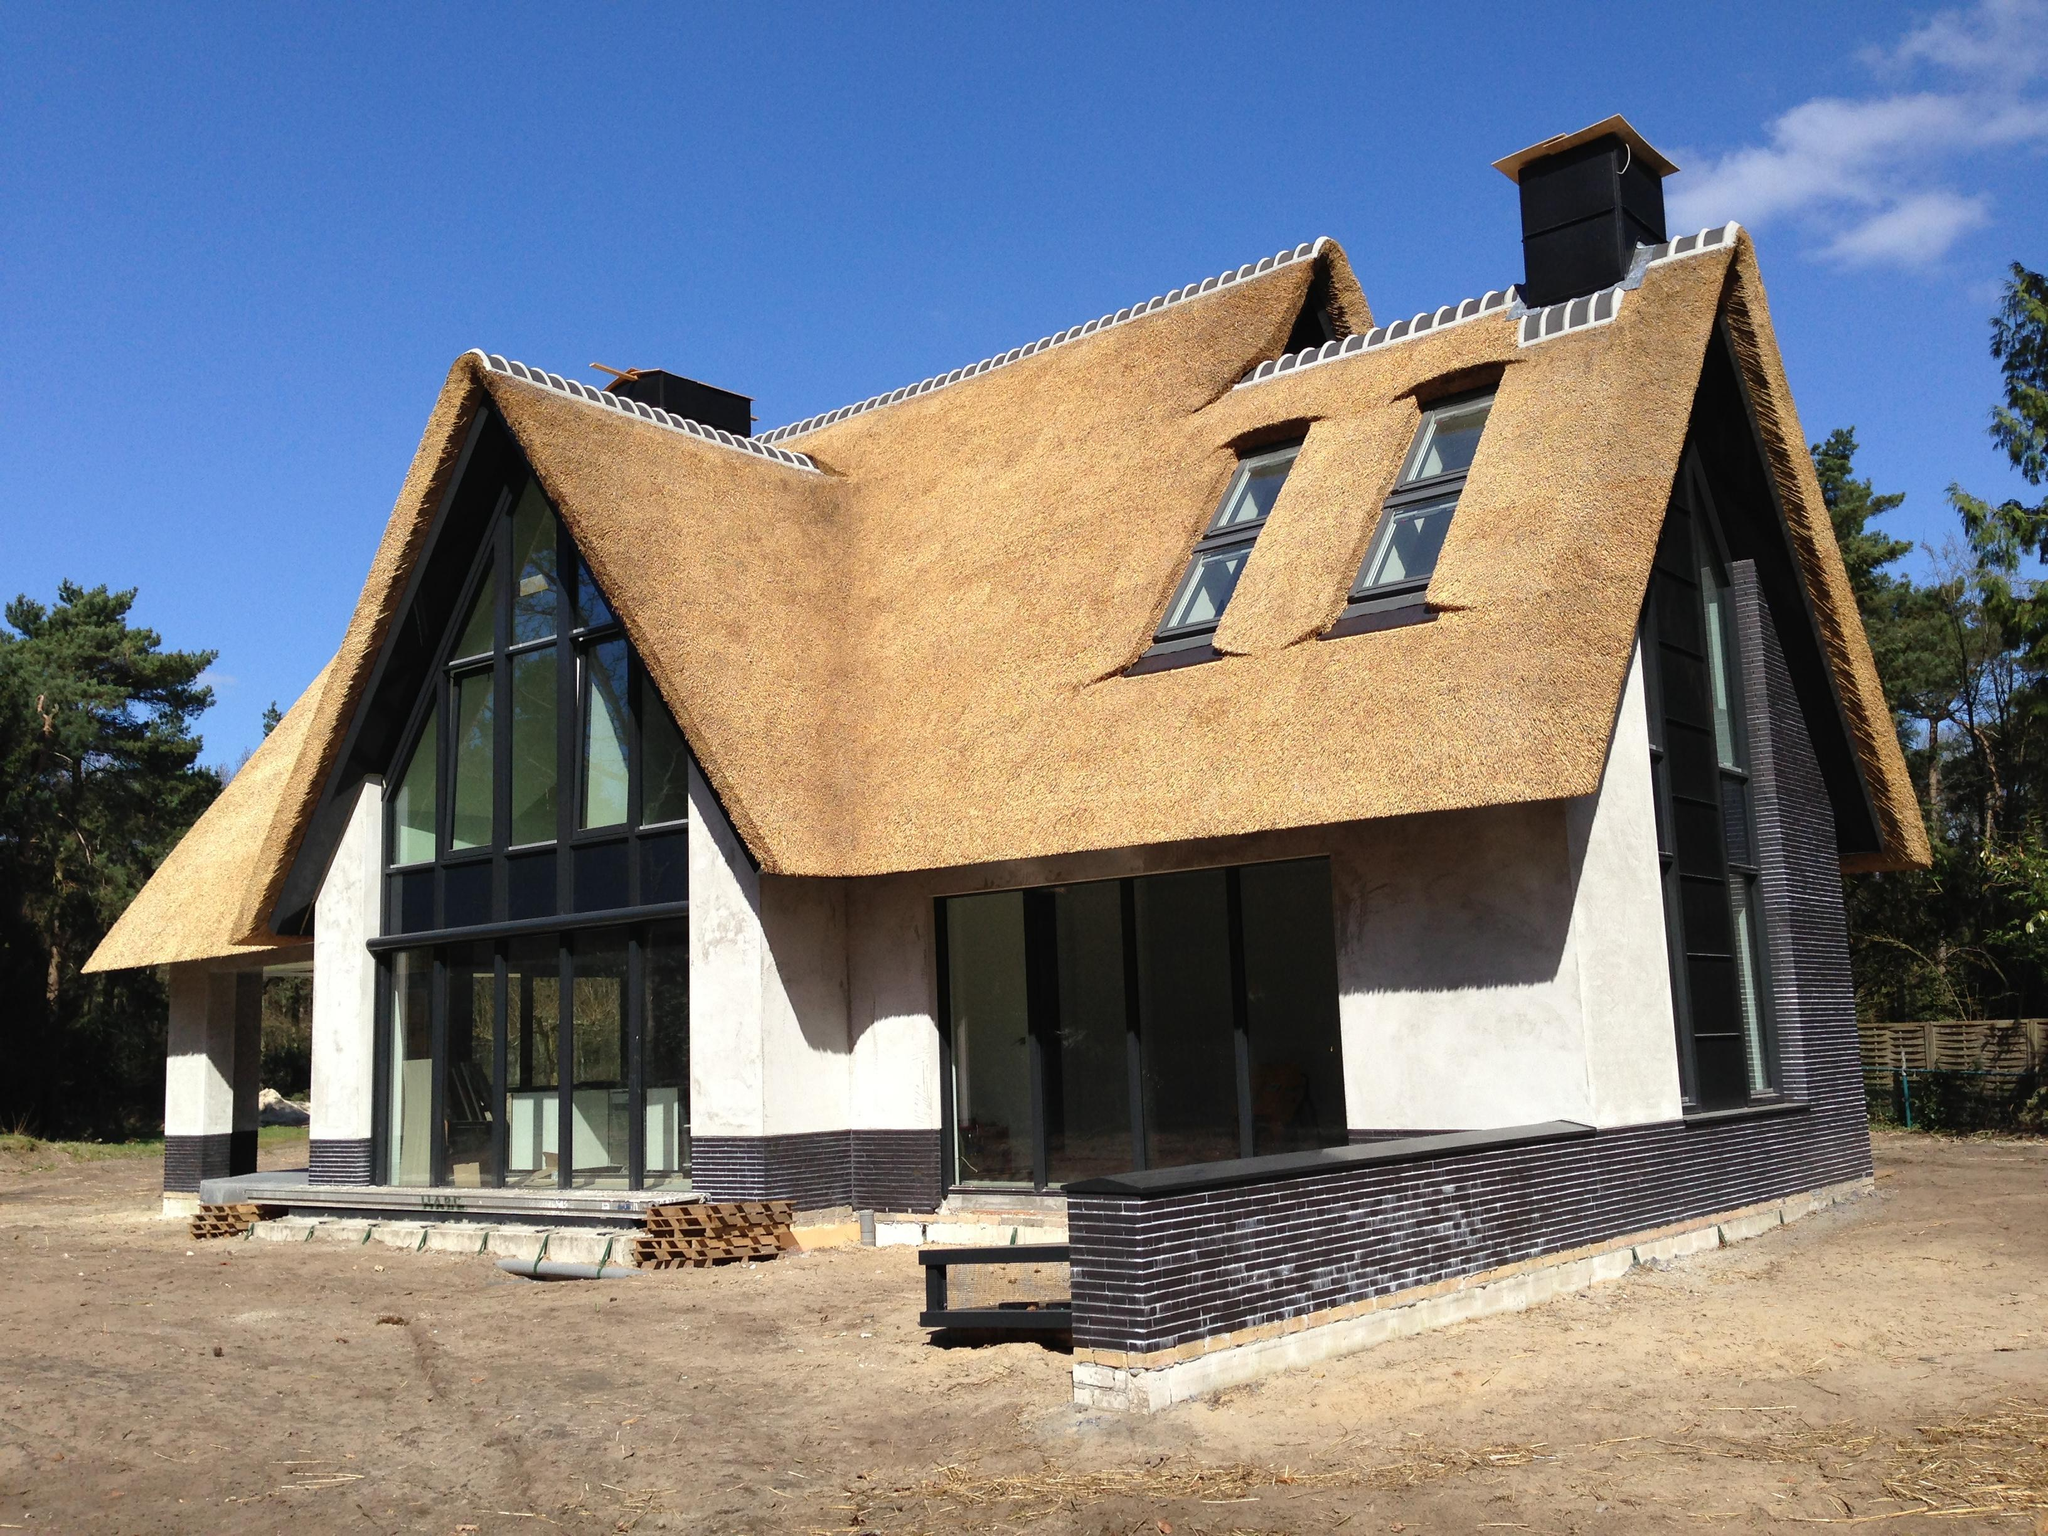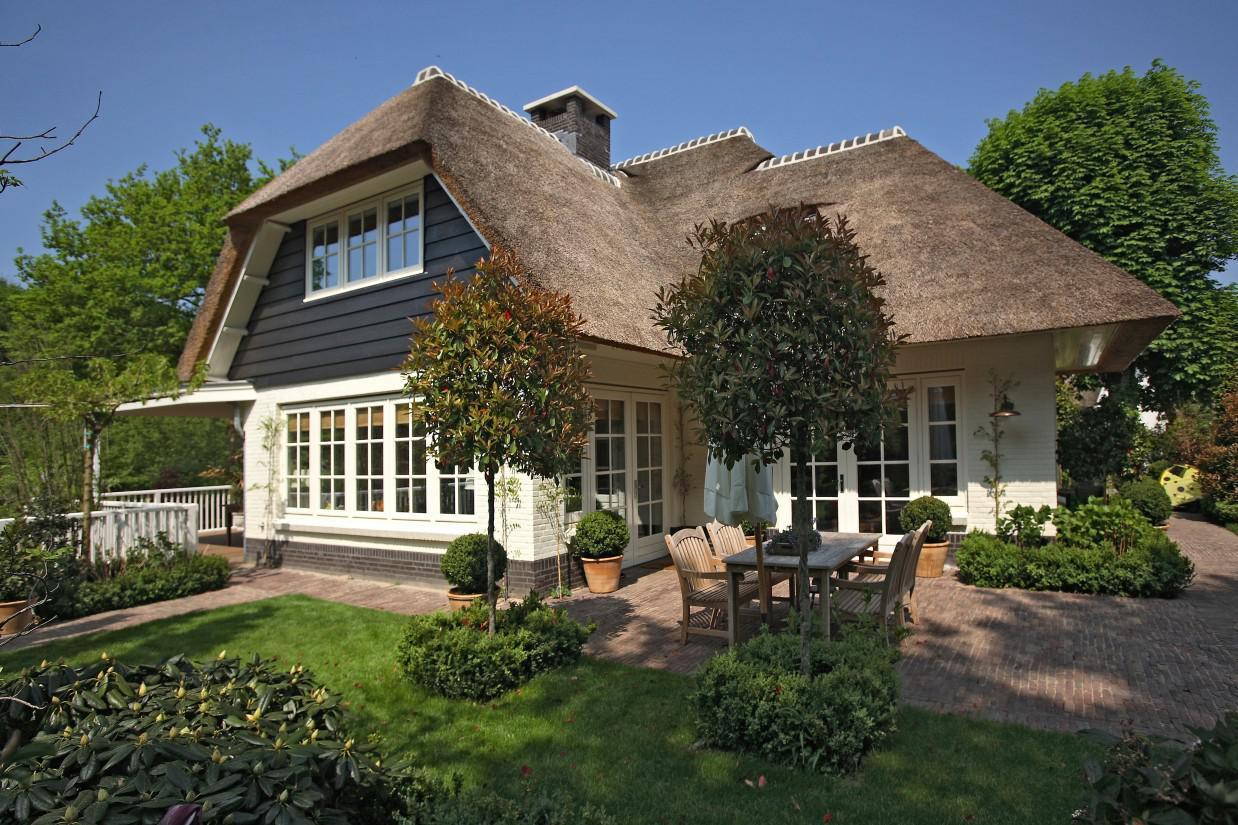The first image is the image on the left, the second image is the image on the right. Analyze the images presented: Is the assertion "The left image shows a white house with a projecting front filled with black-paned windows and covered with a peaked roof, and windows that are surrounded by grayish-brown roof." valid? Answer yes or no. Yes. 